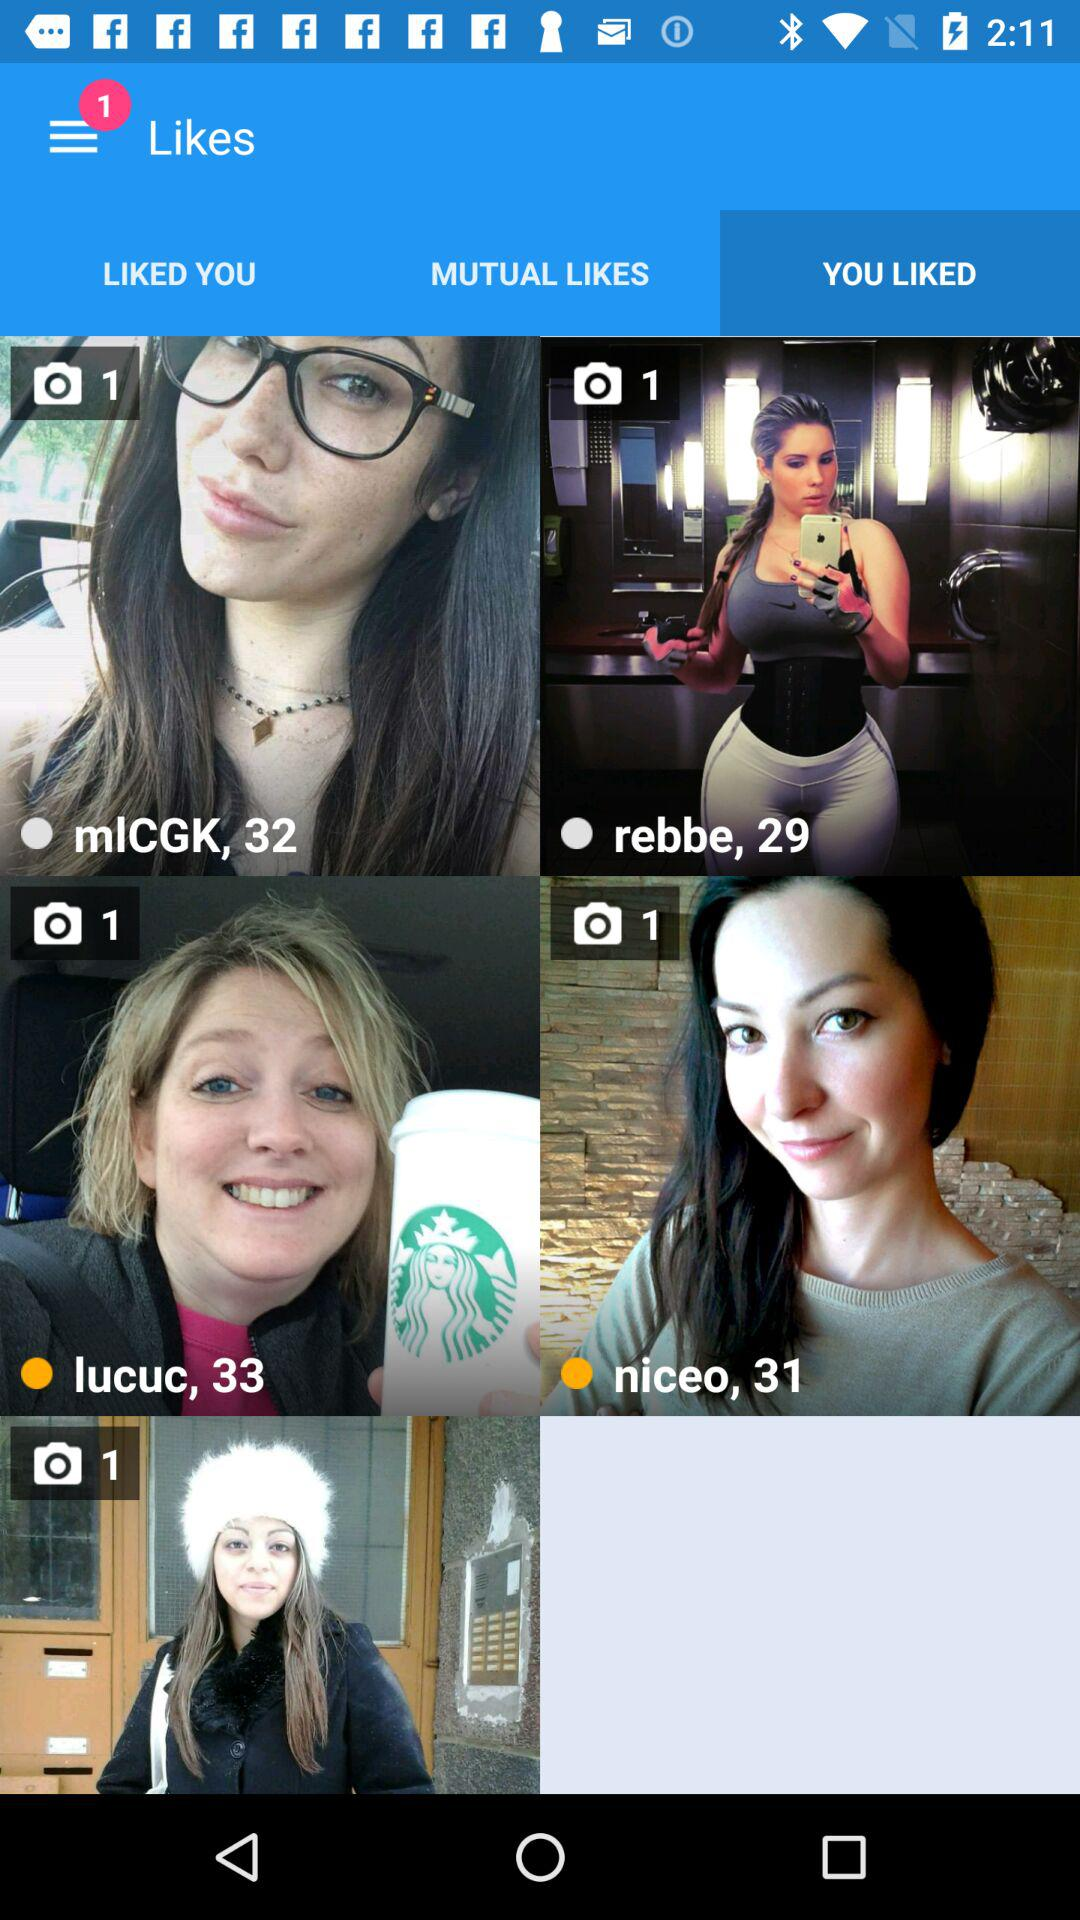How many people have liked you?
When the provided information is insufficient, respond with <no answer>. <no answer> 